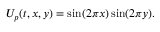<formula> <loc_0><loc_0><loc_500><loc_500>U _ { p } ( t , x , y ) = \sin ( 2 \pi x ) \sin ( 2 \pi y ) .</formula> 